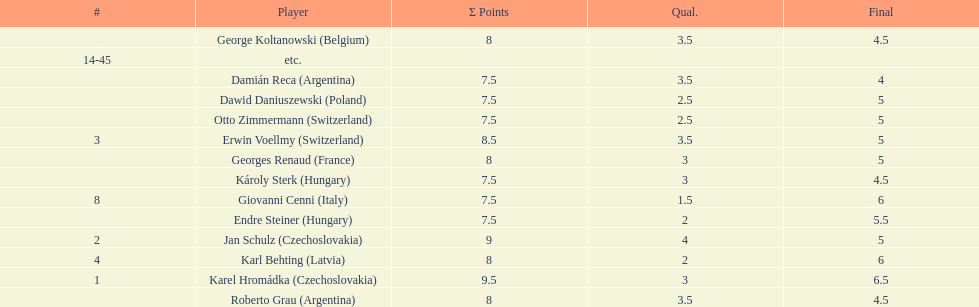What were the concluding scores of karl behting and giovanni cenni each? 6. 